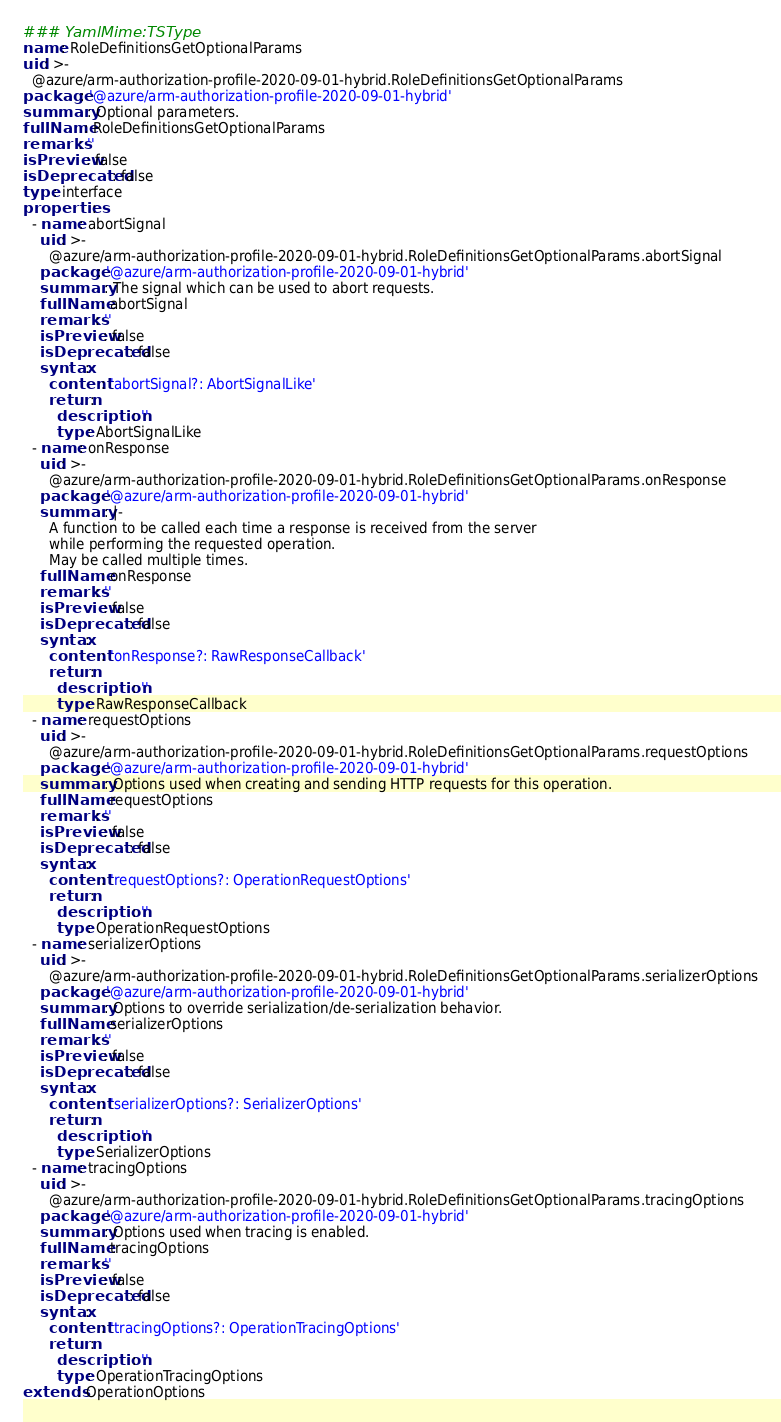<code> <loc_0><loc_0><loc_500><loc_500><_YAML_>### YamlMime:TSType
name: RoleDefinitionsGetOptionalParams
uid: >-
  @azure/arm-authorization-profile-2020-09-01-hybrid.RoleDefinitionsGetOptionalParams
package: '@azure/arm-authorization-profile-2020-09-01-hybrid'
summary: Optional parameters.
fullName: RoleDefinitionsGetOptionalParams
remarks: ''
isPreview: false
isDeprecated: false
type: interface
properties:
  - name: abortSignal
    uid: >-
      @azure/arm-authorization-profile-2020-09-01-hybrid.RoleDefinitionsGetOptionalParams.abortSignal
    package: '@azure/arm-authorization-profile-2020-09-01-hybrid'
    summary: The signal which can be used to abort requests.
    fullName: abortSignal
    remarks: ''
    isPreview: false
    isDeprecated: false
    syntax:
      content: 'abortSignal?: AbortSignalLike'
      return:
        description: ''
        type: AbortSignalLike
  - name: onResponse
    uid: >-
      @azure/arm-authorization-profile-2020-09-01-hybrid.RoleDefinitionsGetOptionalParams.onResponse
    package: '@azure/arm-authorization-profile-2020-09-01-hybrid'
    summary: |-
      A function to be called each time a response is received from the server
      while performing the requested operation.
      May be called multiple times.
    fullName: onResponse
    remarks: ''
    isPreview: false
    isDeprecated: false
    syntax:
      content: 'onResponse?: RawResponseCallback'
      return:
        description: ''
        type: RawResponseCallback
  - name: requestOptions
    uid: >-
      @azure/arm-authorization-profile-2020-09-01-hybrid.RoleDefinitionsGetOptionalParams.requestOptions
    package: '@azure/arm-authorization-profile-2020-09-01-hybrid'
    summary: Options used when creating and sending HTTP requests for this operation.
    fullName: requestOptions
    remarks: ''
    isPreview: false
    isDeprecated: false
    syntax:
      content: 'requestOptions?: OperationRequestOptions'
      return:
        description: ''
        type: OperationRequestOptions
  - name: serializerOptions
    uid: >-
      @azure/arm-authorization-profile-2020-09-01-hybrid.RoleDefinitionsGetOptionalParams.serializerOptions
    package: '@azure/arm-authorization-profile-2020-09-01-hybrid'
    summary: Options to override serialization/de-serialization behavior.
    fullName: serializerOptions
    remarks: ''
    isPreview: false
    isDeprecated: false
    syntax:
      content: 'serializerOptions?: SerializerOptions'
      return:
        description: ''
        type: SerializerOptions
  - name: tracingOptions
    uid: >-
      @azure/arm-authorization-profile-2020-09-01-hybrid.RoleDefinitionsGetOptionalParams.tracingOptions
    package: '@azure/arm-authorization-profile-2020-09-01-hybrid'
    summary: Options used when tracing is enabled.
    fullName: tracingOptions
    remarks: ''
    isPreview: false
    isDeprecated: false
    syntax:
      content: 'tracingOptions?: OperationTracingOptions'
      return:
        description: ''
        type: OperationTracingOptions
extends: OperationOptions
</code> 